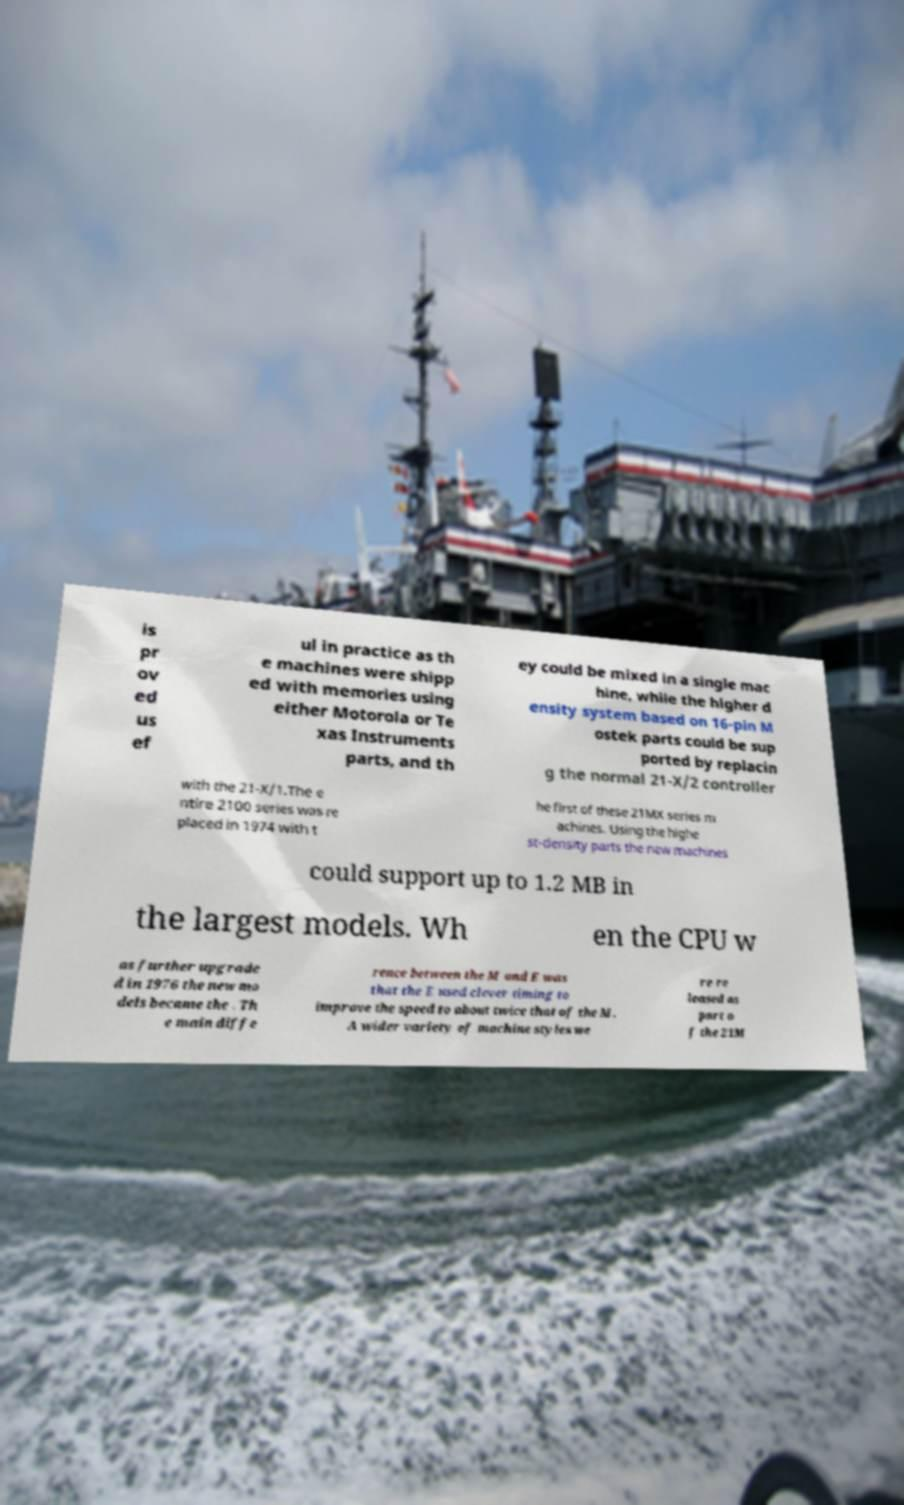What messages or text are displayed in this image? I need them in a readable, typed format. is pr ov ed us ef ul in practice as th e machines were shipp ed with memories using either Motorola or Te xas Instruments parts, and th ey could be mixed in a single mac hine, while the higher d ensity system based on 16-pin M ostek parts could be sup ported by replacin g the normal 21-X/2 controller with the 21-X/1.The e ntire 2100 series was re placed in 1974 with t he first of these 21MX series m achines. Using the highe st-density parts the new machines could support up to 1.2 MB in the largest models. Wh en the CPU w as further upgrade d in 1976 the new mo dels became the . Th e main diffe rence between the M and E was that the E used clever timing to improve the speed to about twice that of the M. A wider variety of machine styles we re re leased as part o f the 21M 